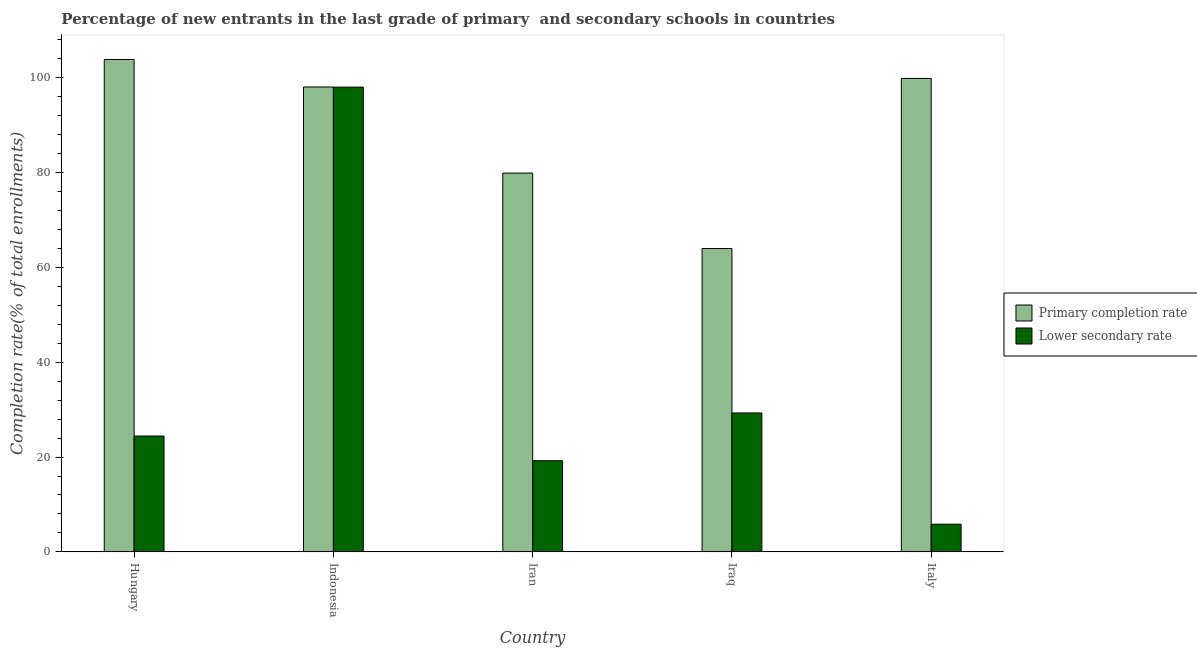How many groups of bars are there?
Provide a short and direct response. 5. What is the label of the 4th group of bars from the left?
Make the answer very short. Iraq. In how many cases, is the number of bars for a given country not equal to the number of legend labels?
Make the answer very short. 0. What is the completion rate in primary schools in Iraq?
Give a very brief answer. 63.99. Across all countries, what is the maximum completion rate in secondary schools?
Make the answer very short. 98.04. Across all countries, what is the minimum completion rate in primary schools?
Ensure brevity in your answer.  63.99. In which country was the completion rate in secondary schools maximum?
Your answer should be compact. Indonesia. In which country was the completion rate in primary schools minimum?
Ensure brevity in your answer.  Iraq. What is the total completion rate in primary schools in the graph?
Make the answer very short. 445.71. What is the difference between the completion rate in secondary schools in Iran and that in Iraq?
Provide a succinct answer. -10.07. What is the difference between the completion rate in primary schools in Italy and the completion rate in secondary schools in Hungary?
Offer a terse response. 75.44. What is the average completion rate in primary schools per country?
Provide a succinct answer. 89.14. What is the difference between the completion rate in secondary schools and completion rate in primary schools in Hungary?
Keep it short and to the point. -79.43. In how many countries, is the completion rate in primary schools greater than 52 %?
Make the answer very short. 5. What is the ratio of the completion rate in primary schools in Hungary to that in Iraq?
Ensure brevity in your answer.  1.62. Is the completion rate in secondary schools in Indonesia less than that in Iraq?
Provide a short and direct response. No. What is the difference between the highest and the second highest completion rate in primary schools?
Ensure brevity in your answer.  3.99. What is the difference between the highest and the lowest completion rate in primary schools?
Your answer should be very brief. 39.87. In how many countries, is the completion rate in primary schools greater than the average completion rate in primary schools taken over all countries?
Offer a very short reply. 3. What does the 1st bar from the left in Italy represents?
Give a very brief answer. Primary completion rate. What does the 1st bar from the right in Indonesia represents?
Provide a short and direct response. Lower secondary rate. Are all the bars in the graph horizontal?
Keep it short and to the point. No. What is the difference between two consecutive major ticks on the Y-axis?
Give a very brief answer. 20. Does the graph contain any zero values?
Keep it short and to the point. No. Does the graph contain grids?
Your answer should be very brief. No. Where does the legend appear in the graph?
Provide a short and direct response. Center right. How many legend labels are there?
Provide a succinct answer. 2. How are the legend labels stacked?
Ensure brevity in your answer.  Vertical. What is the title of the graph?
Make the answer very short. Percentage of new entrants in the last grade of primary  and secondary schools in countries. Does "Depositors" appear as one of the legend labels in the graph?
Make the answer very short. No. What is the label or title of the Y-axis?
Ensure brevity in your answer.  Completion rate(% of total enrollments). What is the Completion rate(% of total enrollments) in Primary completion rate in Hungary?
Provide a short and direct response. 103.87. What is the Completion rate(% of total enrollments) of Lower secondary rate in Hungary?
Ensure brevity in your answer.  24.44. What is the Completion rate(% of total enrollments) of Primary completion rate in Indonesia?
Give a very brief answer. 98.07. What is the Completion rate(% of total enrollments) in Lower secondary rate in Indonesia?
Your answer should be compact. 98.04. What is the Completion rate(% of total enrollments) in Primary completion rate in Iran?
Ensure brevity in your answer.  79.91. What is the Completion rate(% of total enrollments) of Lower secondary rate in Iran?
Offer a terse response. 19.23. What is the Completion rate(% of total enrollments) of Primary completion rate in Iraq?
Make the answer very short. 63.99. What is the Completion rate(% of total enrollments) of Lower secondary rate in Iraq?
Your response must be concise. 29.3. What is the Completion rate(% of total enrollments) in Primary completion rate in Italy?
Ensure brevity in your answer.  99.88. What is the Completion rate(% of total enrollments) of Lower secondary rate in Italy?
Provide a short and direct response. 5.84. Across all countries, what is the maximum Completion rate(% of total enrollments) of Primary completion rate?
Provide a succinct answer. 103.87. Across all countries, what is the maximum Completion rate(% of total enrollments) of Lower secondary rate?
Offer a terse response. 98.04. Across all countries, what is the minimum Completion rate(% of total enrollments) in Primary completion rate?
Ensure brevity in your answer.  63.99. Across all countries, what is the minimum Completion rate(% of total enrollments) in Lower secondary rate?
Give a very brief answer. 5.84. What is the total Completion rate(% of total enrollments) in Primary completion rate in the graph?
Offer a very short reply. 445.71. What is the total Completion rate(% of total enrollments) in Lower secondary rate in the graph?
Your answer should be very brief. 176.85. What is the difference between the Completion rate(% of total enrollments) of Lower secondary rate in Hungary and that in Indonesia?
Keep it short and to the point. -73.6. What is the difference between the Completion rate(% of total enrollments) in Primary completion rate in Hungary and that in Iran?
Offer a very short reply. 23.96. What is the difference between the Completion rate(% of total enrollments) of Lower secondary rate in Hungary and that in Iran?
Give a very brief answer. 5.21. What is the difference between the Completion rate(% of total enrollments) of Primary completion rate in Hungary and that in Iraq?
Your answer should be very brief. 39.87. What is the difference between the Completion rate(% of total enrollments) in Lower secondary rate in Hungary and that in Iraq?
Your answer should be compact. -4.86. What is the difference between the Completion rate(% of total enrollments) in Primary completion rate in Hungary and that in Italy?
Provide a short and direct response. 3.99. What is the difference between the Completion rate(% of total enrollments) in Lower secondary rate in Hungary and that in Italy?
Provide a succinct answer. 18.6. What is the difference between the Completion rate(% of total enrollments) in Primary completion rate in Indonesia and that in Iran?
Your answer should be very brief. 18.16. What is the difference between the Completion rate(% of total enrollments) in Lower secondary rate in Indonesia and that in Iran?
Give a very brief answer. 78.81. What is the difference between the Completion rate(% of total enrollments) of Primary completion rate in Indonesia and that in Iraq?
Offer a very short reply. 34.07. What is the difference between the Completion rate(% of total enrollments) in Lower secondary rate in Indonesia and that in Iraq?
Offer a terse response. 68.74. What is the difference between the Completion rate(% of total enrollments) of Primary completion rate in Indonesia and that in Italy?
Your answer should be compact. -1.81. What is the difference between the Completion rate(% of total enrollments) of Lower secondary rate in Indonesia and that in Italy?
Make the answer very short. 92.2. What is the difference between the Completion rate(% of total enrollments) in Primary completion rate in Iran and that in Iraq?
Give a very brief answer. 15.91. What is the difference between the Completion rate(% of total enrollments) in Lower secondary rate in Iran and that in Iraq?
Provide a succinct answer. -10.07. What is the difference between the Completion rate(% of total enrollments) in Primary completion rate in Iran and that in Italy?
Provide a succinct answer. -19.97. What is the difference between the Completion rate(% of total enrollments) in Lower secondary rate in Iran and that in Italy?
Keep it short and to the point. 13.39. What is the difference between the Completion rate(% of total enrollments) of Primary completion rate in Iraq and that in Italy?
Provide a succinct answer. -35.88. What is the difference between the Completion rate(% of total enrollments) of Lower secondary rate in Iraq and that in Italy?
Offer a terse response. 23.46. What is the difference between the Completion rate(% of total enrollments) in Primary completion rate in Hungary and the Completion rate(% of total enrollments) in Lower secondary rate in Indonesia?
Your response must be concise. 5.83. What is the difference between the Completion rate(% of total enrollments) in Primary completion rate in Hungary and the Completion rate(% of total enrollments) in Lower secondary rate in Iran?
Your answer should be compact. 84.63. What is the difference between the Completion rate(% of total enrollments) of Primary completion rate in Hungary and the Completion rate(% of total enrollments) of Lower secondary rate in Iraq?
Your answer should be compact. 74.56. What is the difference between the Completion rate(% of total enrollments) in Primary completion rate in Hungary and the Completion rate(% of total enrollments) in Lower secondary rate in Italy?
Provide a short and direct response. 98.03. What is the difference between the Completion rate(% of total enrollments) in Primary completion rate in Indonesia and the Completion rate(% of total enrollments) in Lower secondary rate in Iran?
Provide a short and direct response. 78.83. What is the difference between the Completion rate(% of total enrollments) in Primary completion rate in Indonesia and the Completion rate(% of total enrollments) in Lower secondary rate in Iraq?
Give a very brief answer. 68.76. What is the difference between the Completion rate(% of total enrollments) of Primary completion rate in Indonesia and the Completion rate(% of total enrollments) of Lower secondary rate in Italy?
Provide a succinct answer. 92.23. What is the difference between the Completion rate(% of total enrollments) in Primary completion rate in Iran and the Completion rate(% of total enrollments) in Lower secondary rate in Iraq?
Give a very brief answer. 50.61. What is the difference between the Completion rate(% of total enrollments) of Primary completion rate in Iran and the Completion rate(% of total enrollments) of Lower secondary rate in Italy?
Offer a very short reply. 74.07. What is the difference between the Completion rate(% of total enrollments) of Primary completion rate in Iraq and the Completion rate(% of total enrollments) of Lower secondary rate in Italy?
Keep it short and to the point. 58.15. What is the average Completion rate(% of total enrollments) of Primary completion rate per country?
Offer a very short reply. 89.14. What is the average Completion rate(% of total enrollments) in Lower secondary rate per country?
Provide a short and direct response. 35.37. What is the difference between the Completion rate(% of total enrollments) in Primary completion rate and Completion rate(% of total enrollments) in Lower secondary rate in Hungary?
Offer a very short reply. 79.43. What is the difference between the Completion rate(% of total enrollments) in Primary completion rate and Completion rate(% of total enrollments) in Lower secondary rate in Indonesia?
Offer a terse response. 0.03. What is the difference between the Completion rate(% of total enrollments) of Primary completion rate and Completion rate(% of total enrollments) of Lower secondary rate in Iran?
Give a very brief answer. 60.68. What is the difference between the Completion rate(% of total enrollments) of Primary completion rate and Completion rate(% of total enrollments) of Lower secondary rate in Iraq?
Give a very brief answer. 34.69. What is the difference between the Completion rate(% of total enrollments) in Primary completion rate and Completion rate(% of total enrollments) in Lower secondary rate in Italy?
Offer a terse response. 94.04. What is the ratio of the Completion rate(% of total enrollments) in Primary completion rate in Hungary to that in Indonesia?
Provide a succinct answer. 1.06. What is the ratio of the Completion rate(% of total enrollments) in Lower secondary rate in Hungary to that in Indonesia?
Your response must be concise. 0.25. What is the ratio of the Completion rate(% of total enrollments) in Primary completion rate in Hungary to that in Iran?
Provide a short and direct response. 1.3. What is the ratio of the Completion rate(% of total enrollments) of Lower secondary rate in Hungary to that in Iran?
Your answer should be very brief. 1.27. What is the ratio of the Completion rate(% of total enrollments) in Primary completion rate in Hungary to that in Iraq?
Your answer should be very brief. 1.62. What is the ratio of the Completion rate(% of total enrollments) of Lower secondary rate in Hungary to that in Iraq?
Offer a terse response. 0.83. What is the ratio of the Completion rate(% of total enrollments) in Primary completion rate in Hungary to that in Italy?
Your answer should be very brief. 1.04. What is the ratio of the Completion rate(% of total enrollments) in Lower secondary rate in Hungary to that in Italy?
Give a very brief answer. 4.19. What is the ratio of the Completion rate(% of total enrollments) of Primary completion rate in Indonesia to that in Iran?
Keep it short and to the point. 1.23. What is the ratio of the Completion rate(% of total enrollments) in Lower secondary rate in Indonesia to that in Iran?
Offer a very short reply. 5.1. What is the ratio of the Completion rate(% of total enrollments) in Primary completion rate in Indonesia to that in Iraq?
Your answer should be compact. 1.53. What is the ratio of the Completion rate(% of total enrollments) in Lower secondary rate in Indonesia to that in Iraq?
Your answer should be very brief. 3.35. What is the ratio of the Completion rate(% of total enrollments) of Primary completion rate in Indonesia to that in Italy?
Offer a very short reply. 0.98. What is the ratio of the Completion rate(% of total enrollments) of Lower secondary rate in Indonesia to that in Italy?
Provide a short and direct response. 16.79. What is the ratio of the Completion rate(% of total enrollments) in Primary completion rate in Iran to that in Iraq?
Your response must be concise. 1.25. What is the ratio of the Completion rate(% of total enrollments) in Lower secondary rate in Iran to that in Iraq?
Your answer should be very brief. 0.66. What is the ratio of the Completion rate(% of total enrollments) in Primary completion rate in Iran to that in Italy?
Offer a very short reply. 0.8. What is the ratio of the Completion rate(% of total enrollments) of Lower secondary rate in Iran to that in Italy?
Provide a short and direct response. 3.29. What is the ratio of the Completion rate(% of total enrollments) of Primary completion rate in Iraq to that in Italy?
Give a very brief answer. 0.64. What is the ratio of the Completion rate(% of total enrollments) of Lower secondary rate in Iraq to that in Italy?
Your response must be concise. 5.02. What is the difference between the highest and the second highest Completion rate(% of total enrollments) of Primary completion rate?
Provide a short and direct response. 3.99. What is the difference between the highest and the second highest Completion rate(% of total enrollments) in Lower secondary rate?
Keep it short and to the point. 68.74. What is the difference between the highest and the lowest Completion rate(% of total enrollments) in Primary completion rate?
Your answer should be compact. 39.87. What is the difference between the highest and the lowest Completion rate(% of total enrollments) in Lower secondary rate?
Ensure brevity in your answer.  92.2. 